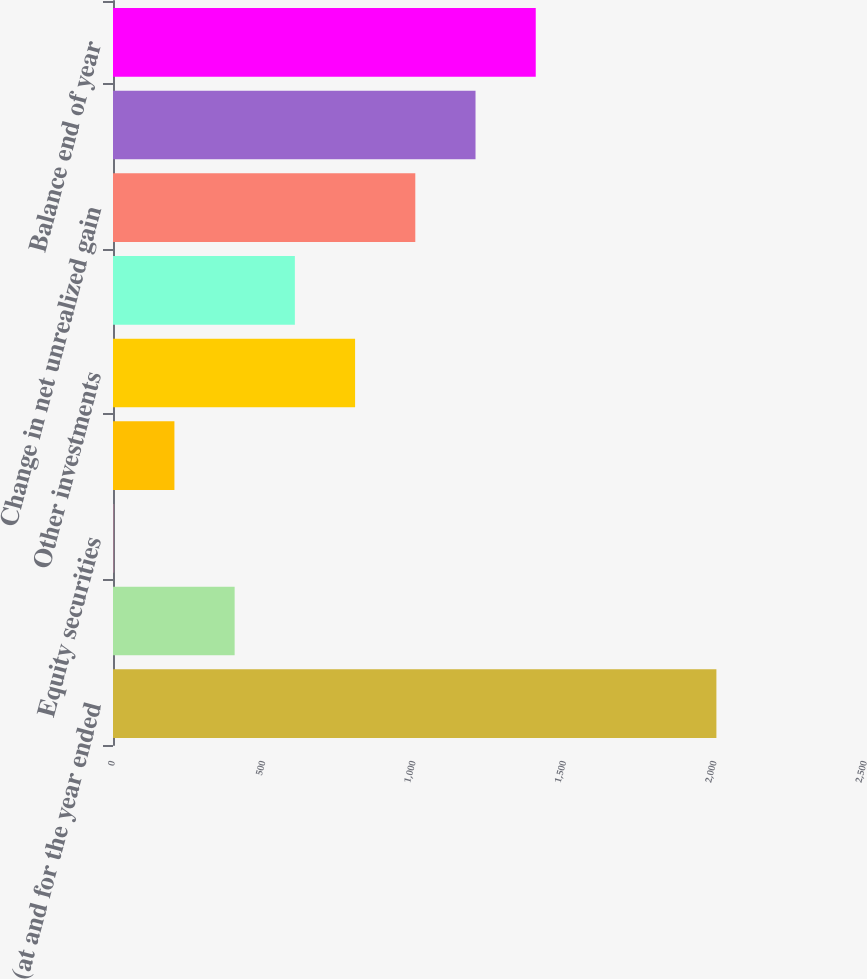Convert chart to OTSL. <chart><loc_0><loc_0><loc_500><loc_500><bar_chart><fcel>(at and for the year ended<fcel>Fixed maturities<fcel>Equity securities<fcel>Venture capital<fcel>Other investments<fcel>Related tax expense (benefit)<fcel>Change in net unrealized gain<fcel>Balance beginning of year<fcel>Balance end of year<nl><fcel>2006<fcel>404.4<fcel>4<fcel>204.2<fcel>804.8<fcel>604.6<fcel>1005<fcel>1205.2<fcel>1405.4<nl></chart> 